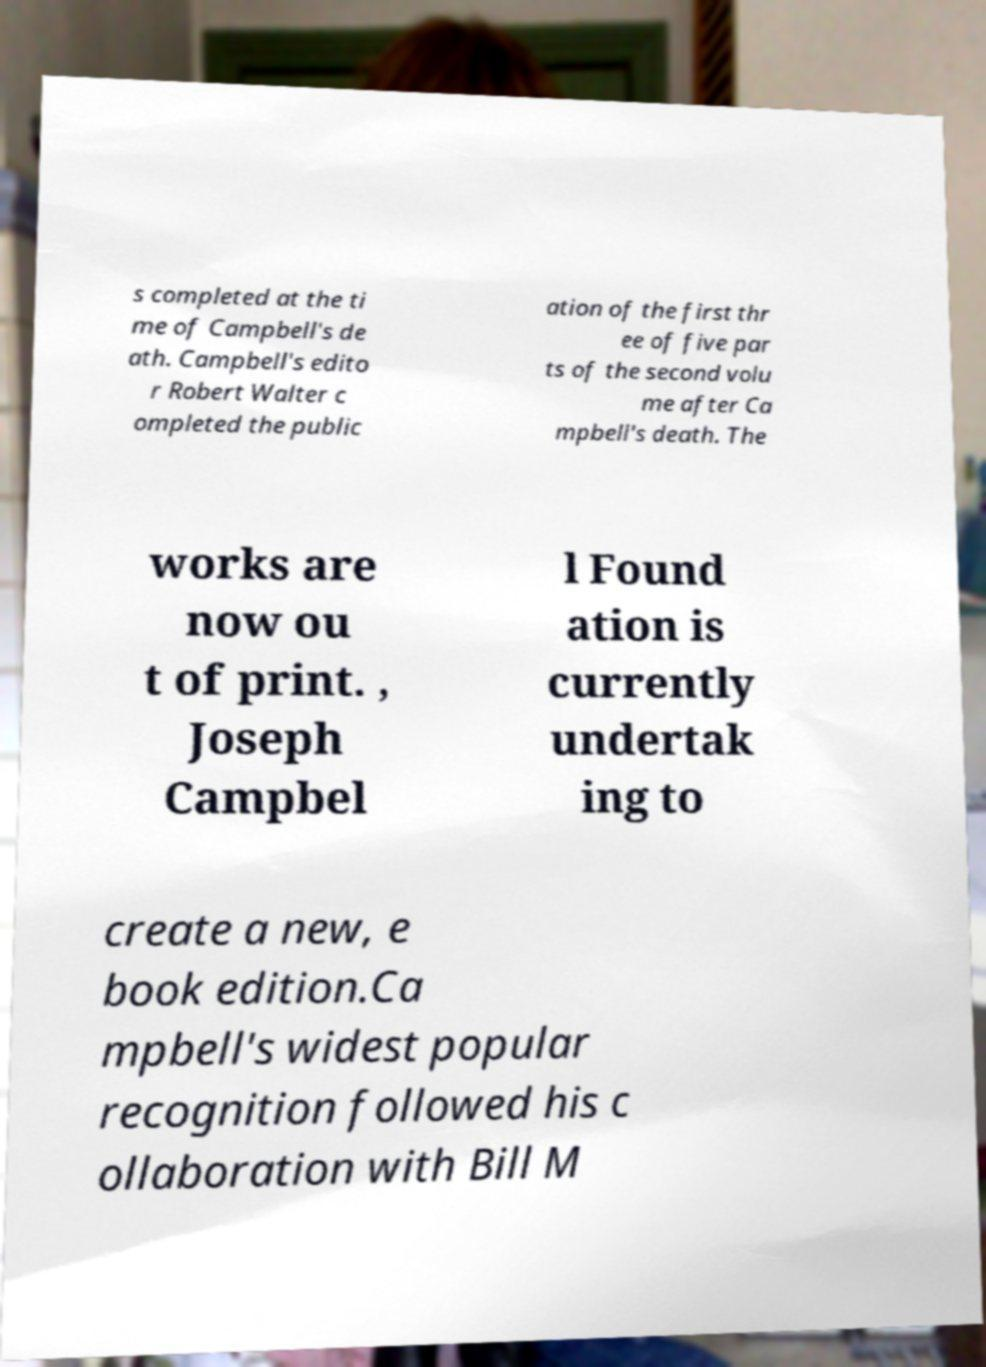What messages or text are displayed in this image? I need them in a readable, typed format. s completed at the ti me of Campbell's de ath. Campbell's edito r Robert Walter c ompleted the public ation of the first thr ee of five par ts of the second volu me after Ca mpbell's death. The works are now ou t of print. , Joseph Campbel l Found ation is currently undertak ing to create a new, e book edition.Ca mpbell's widest popular recognition followed his c ollaboration with Bill M 